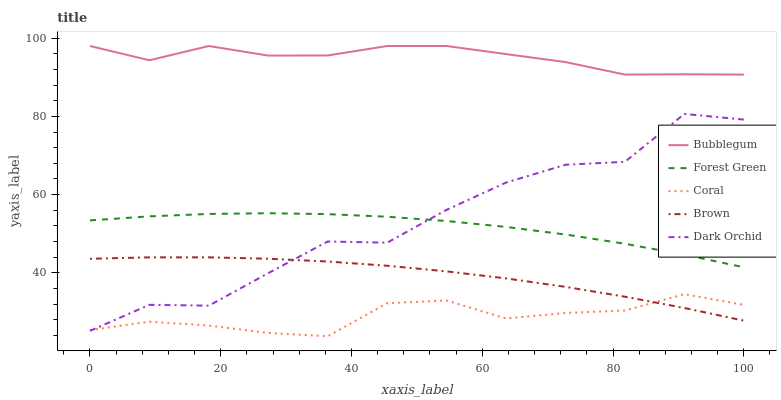Does Brown have the minimum area under the curve?
Answer yes or no. No. Does Brown have the maximum area under the curve?
Answer yes or no. No. Is Forest Green the smoothest?
Answer yes or no. No. Is Forest Green the roughest?
Answer yes or no. No. Does Brown have the lowest value?
Answer yes or no. No. Does Brown have the highest value?
Answer yes or no. No. Is Brown less than Bubblegum?
Answer yes or no. Yes. Is Forest Green greater than Coral?
Answer yes or no. Yes. Does Brown intersect Bubblegum?
Answer yes or no. No. 